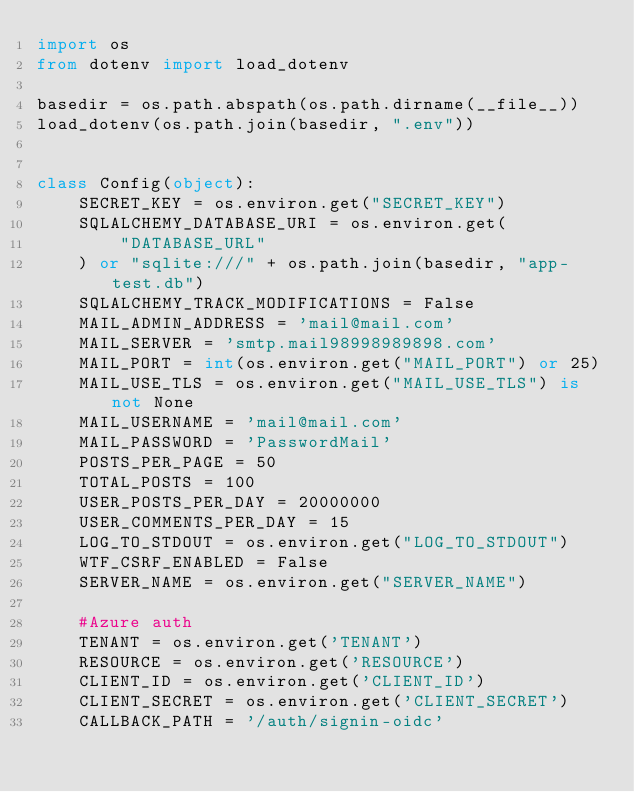Convert code to text. <code><loc_0><loc_0><loc_500><loc_500><_Python_>import os
from dotenv import load_dotenv

basedir = os.path.abspath(os.path.dirname(__file__))
load_dotenv(os.path.join(basedir, ".env"))


class Config(object):
    SECRET_KEY = os.environ.get("SECRET_KEY")
    SQLALCHEMY_DATABASE_URI = os.environ.get(
        "DATABASE_URL"
    ) or "sqlite:///" + os.path.join(basedir, "app-test.db")
    SQLALCHEMY_TRACK_MODIFICATIONS = False
    MAIL_ADMIN_ADDRESS = 'mail@mail.com' 
    MAIL_SERVER = 'smtp.mail98998989898.com' 
    MAIL_PORT = int(os.environ.get("MAIL_PORT") or 25)
    MAIL_USE_TLS = os.environ.get("MAIL_USE_TLS") is not None
    MAIL_USERNAME = 'mail@mail.com'
    MAIL_PASSWORD = 'PasswordMail'
    POSTS_PER_PAGE = 50
    TOTAL_POSTS = 100
    USER_POSTS_PER_DAY = 20000000
    USER_COMMENTS_PER_DAY = 15
    LOG_TO_STDOUT = os.environ.get("LOG_TO_STDOUT")
    WTF_CSRF_ENABLED = False
    SERVER_NAME = os.environ.get("SERVER_NAME")
    
    #Azure auth
    TENANT = os.environ.get('TENANT')
    RESOURCE = os.environ.get('RESOURCE')
    CLIENT_ID = os.environ.get('CLIENT_ID')
    CLIENT_SECRET = os.environ.get('CLIENT_SECRET')
    CALLBACK_PATH = '/auth/signin-oidc'</code> 